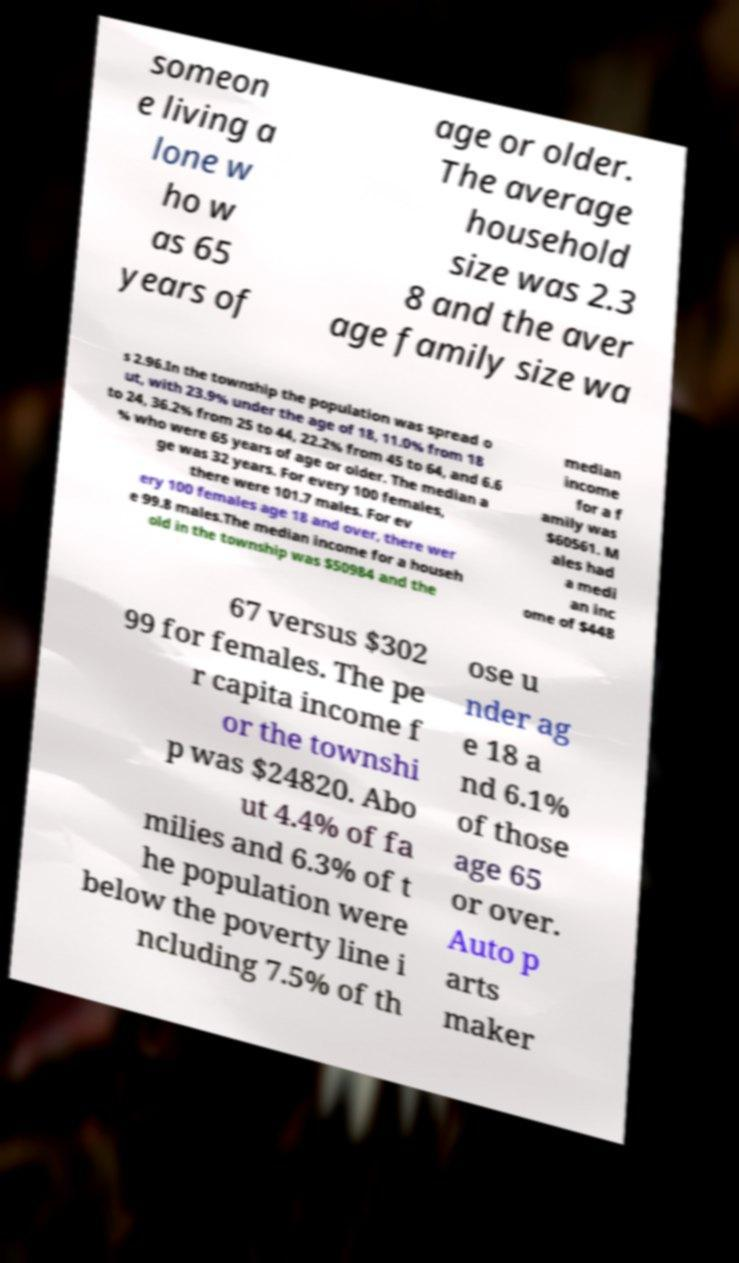What messages or text are displayed in this image? I need them in a readable, typed format. someon e living a lone w ho w as 65 years of age or older. The average household size was 2.3 8 and the aver age family size wa s 2.96.In the township the population was spread o ut, with 23.9% under the age of 18, 11.0% from 18 to 24, 36.2% from 25 to 44, 22.2% from 45 to 64, and 6.6 % who were 65 years of age or older. The median a ge was 32 years. For every 100 females, there were 101.7 males. For ev ery 100 females age 18 and over, there wer e 99.8 males.The median income for a househ old in the township was $50984 and the median income for a f amily was $60561. M ales had a medi an inc ome of $448 67 versus $302 99 for females. The pe r capita income f or the townshi p was $24820. Abo ut 4.4% of fa milies and 6.3% of t he population were below the poverty line i ncluding 7.5% of th ose u nder ag e 18 a nd 6.1% of those age 65 or over. Auto p arts maker 